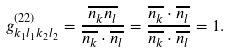<formula> <loc_0><loc_0><loc_500><loc_500>g ^ { ( 2 2 ) } _ { k _ { 1 } l _ { 1 } k _ { 2 } l _ { 2 } } = \frac { \overline { n _ { k } n _ { l } } } { \overline { n _ { k } } \cdot \overline { n _ { l } } } = \frac { \overline { n _ { k } } \cdot \overline { n _ { l } } } { \overline { n _ { k } } \cdot \overline { n _ { l } } } = 1 .</formula> 